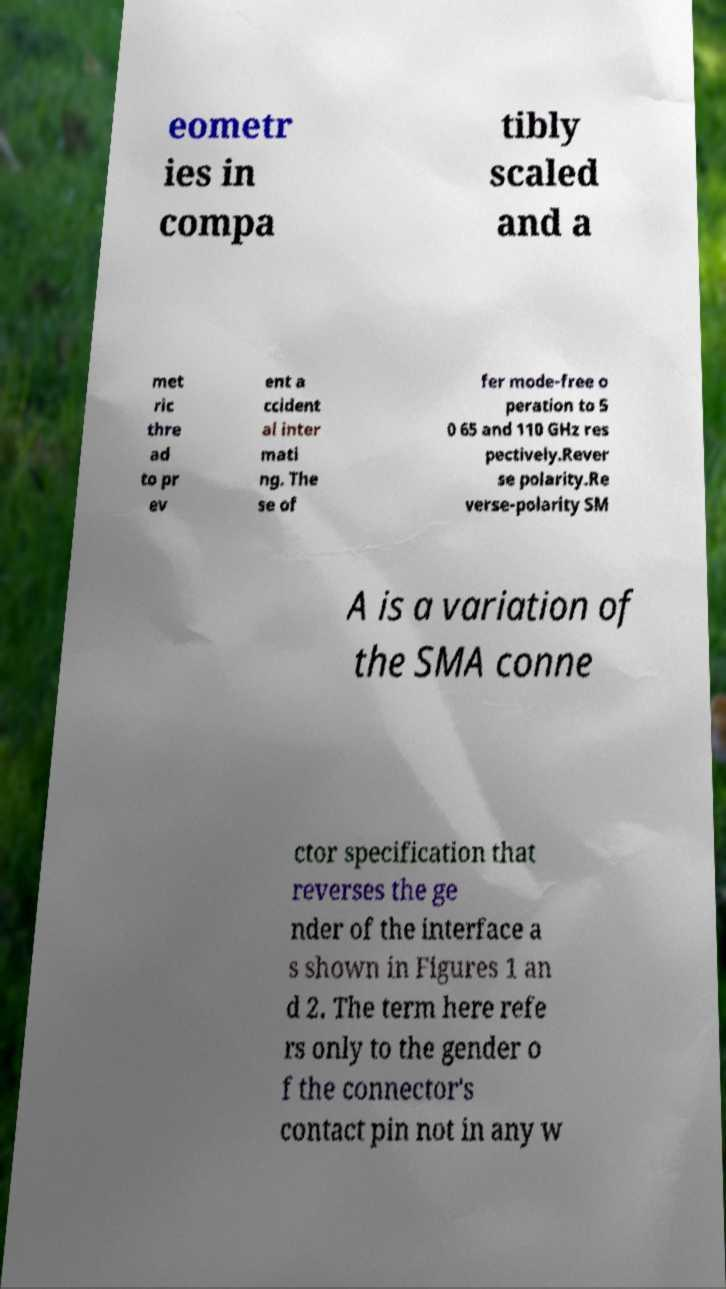Please identify and transcribe the text found in this image. eometr ies in compa tibly scaled and a met ric thre ad to pr ev ent a ccident al inter mati ng. The se of fer mode-free o peration to 5 0 65 and 110 GHz res pectively.Rever se polarity.Re verse-polarity SM A is a variation of the SMA conne ctor specification that reverses the ge nder of the interface a s shown in Figures 1 an d 2. The term here refe rs only to the gender o f the connector's contact pin not in any w 